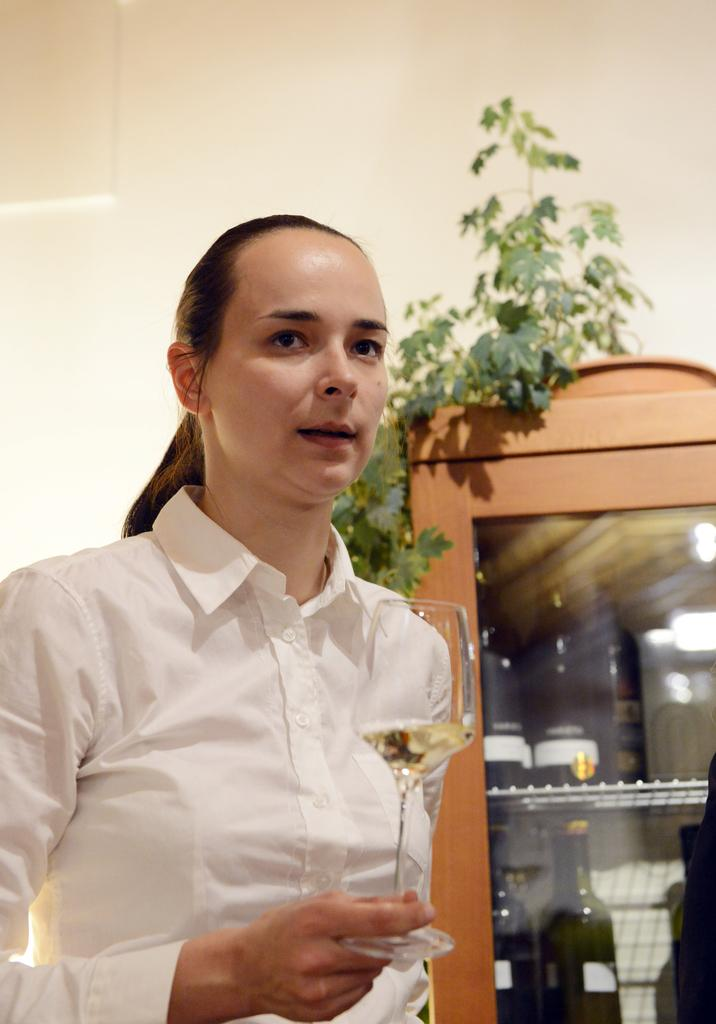Who is the main subject in the image? There is a lady in the image. What is the lady wearing? The lady is wearing a white shirt. What is the lady holding in her right hand? The lady is holding a glass in her right hand. What can be seen on the shelf in the image? There are bottles and a plant on the shelf. What type of pets are visible on the hook in the image? There is no hook or pets present in the image. 